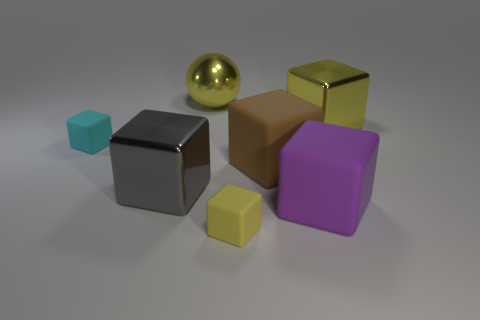How many objects are there in total, and can you describe their colors and materials? In the image, a total of six objects can be observed. Starting from the left, there's a small cyan matte cube, followed by a medium-sized silver matte cube. Next, there's a large brown matte cube, a small yellow matte cube, a large purple matte cube, and finally, a large yellow shiny sphere, which appears to be metallic. 